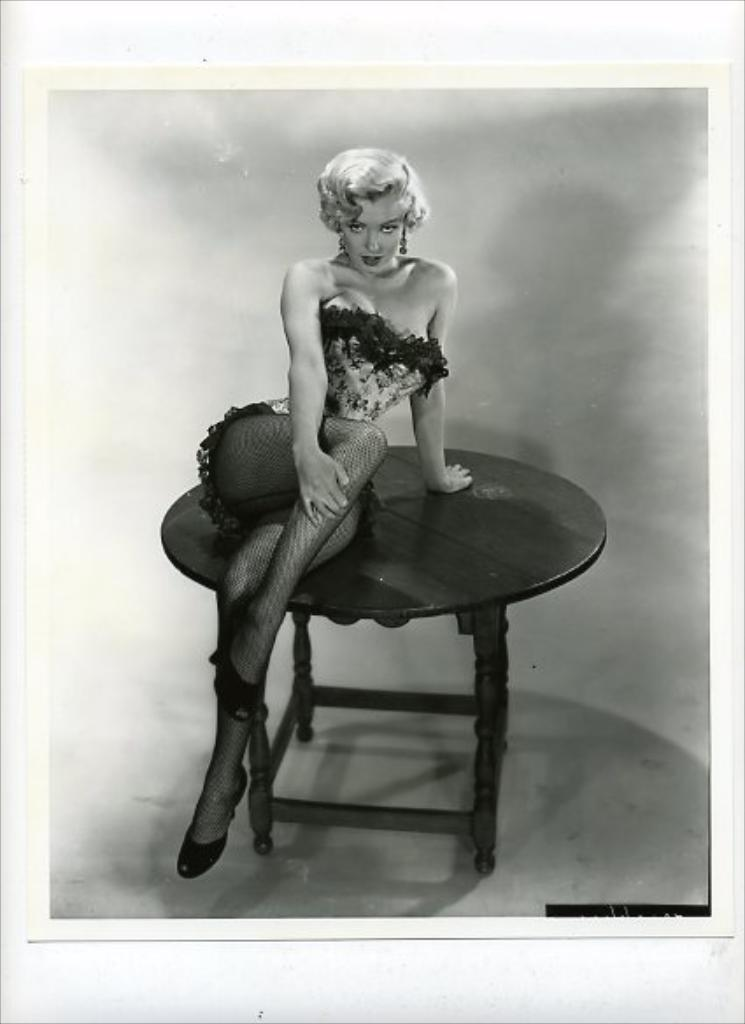Who is the main subject in the image? There is a woman in the image. What is the woman doing in the image? The woman is sitting on a table. What is the price of the stream in the image? There is no stream present in the image, so it is not possible to determine its price. 